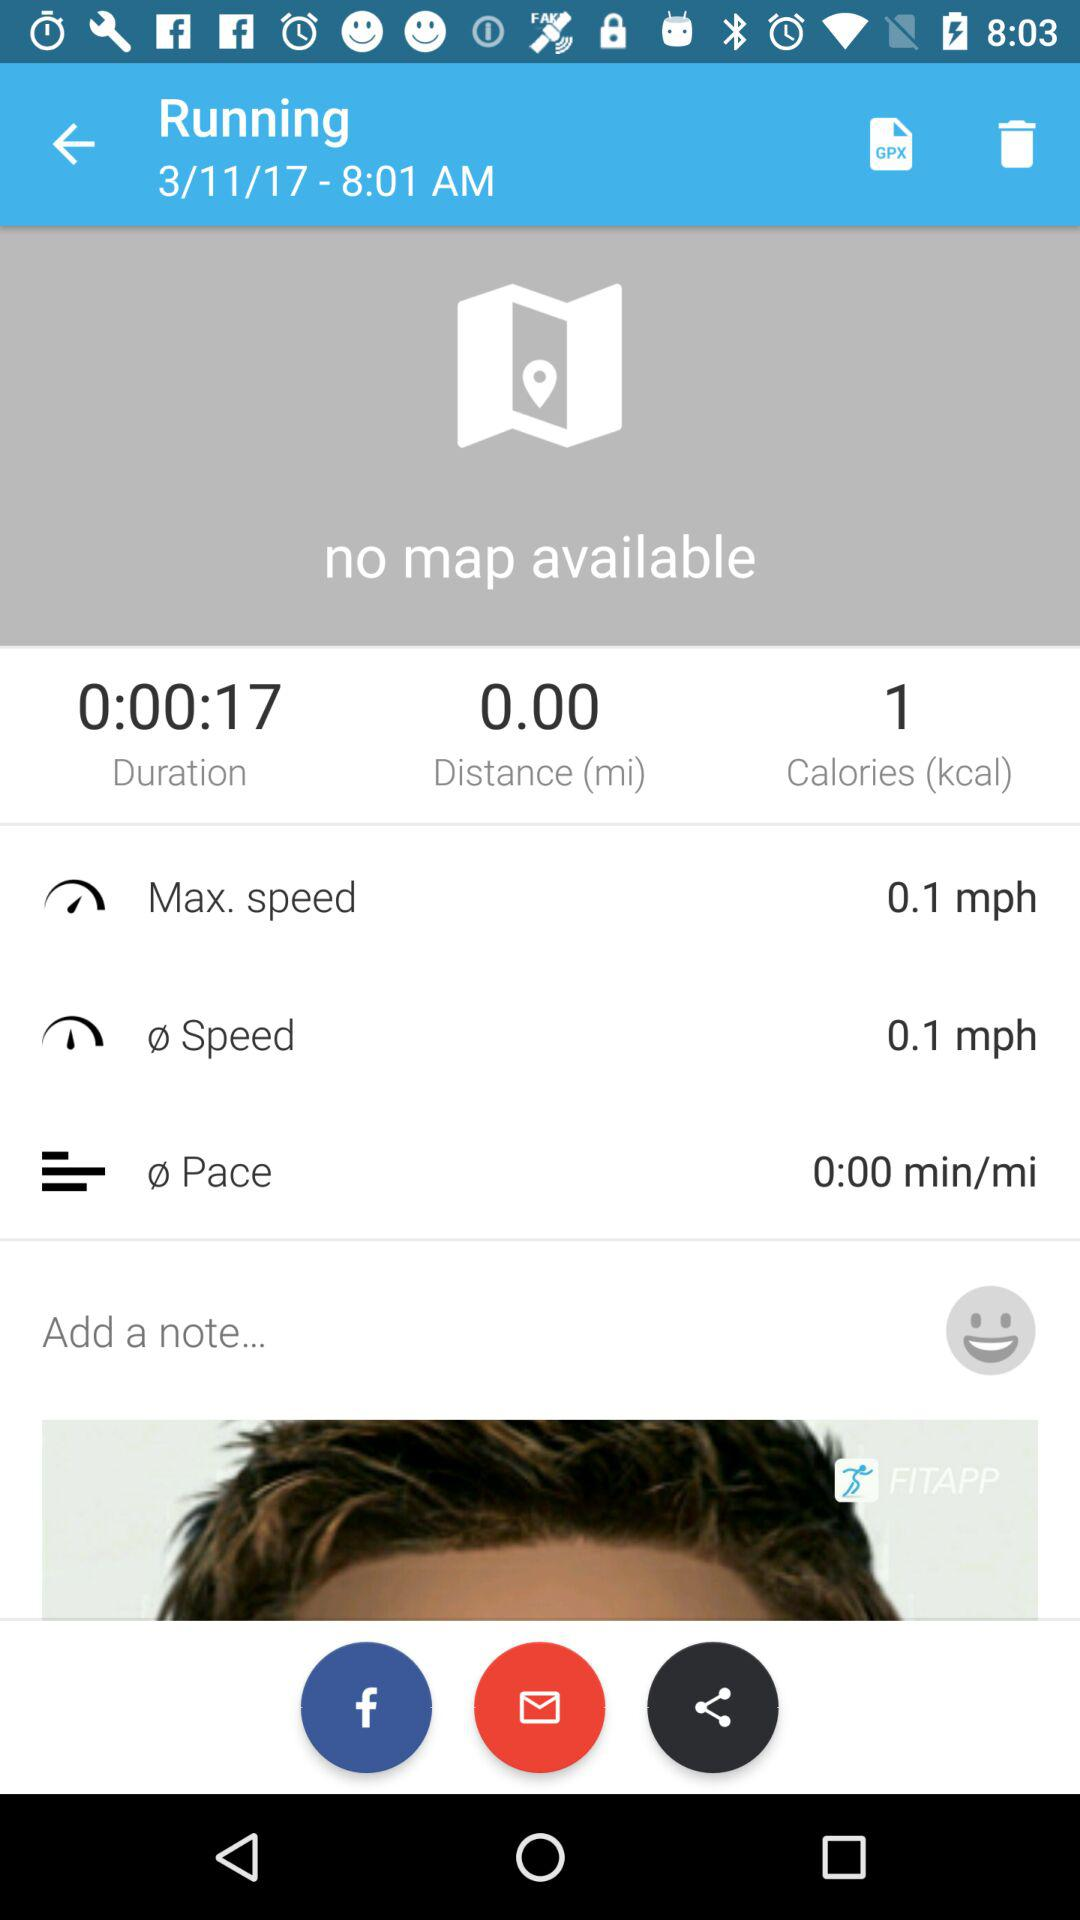What is the amount of calorie? The amount of calorie is 1 kcal. 